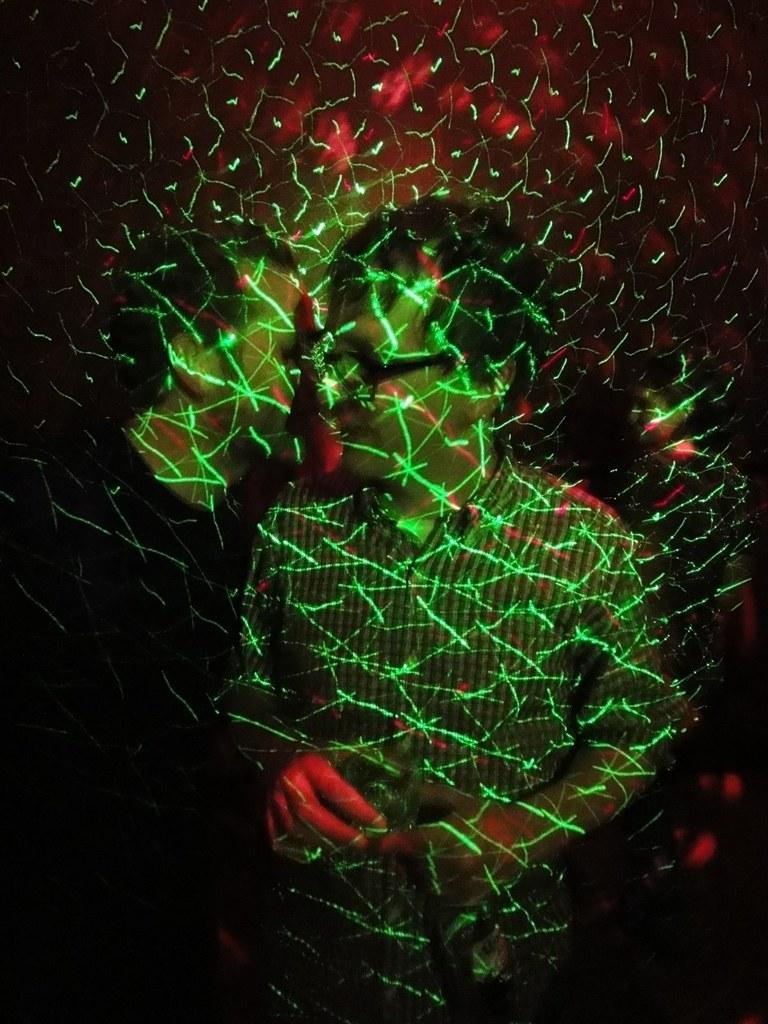Can you describe this image briefly? This image is taken indoors. In the background there is a wall. In the middle of the image a man is standing on the floor and there are a few people. 